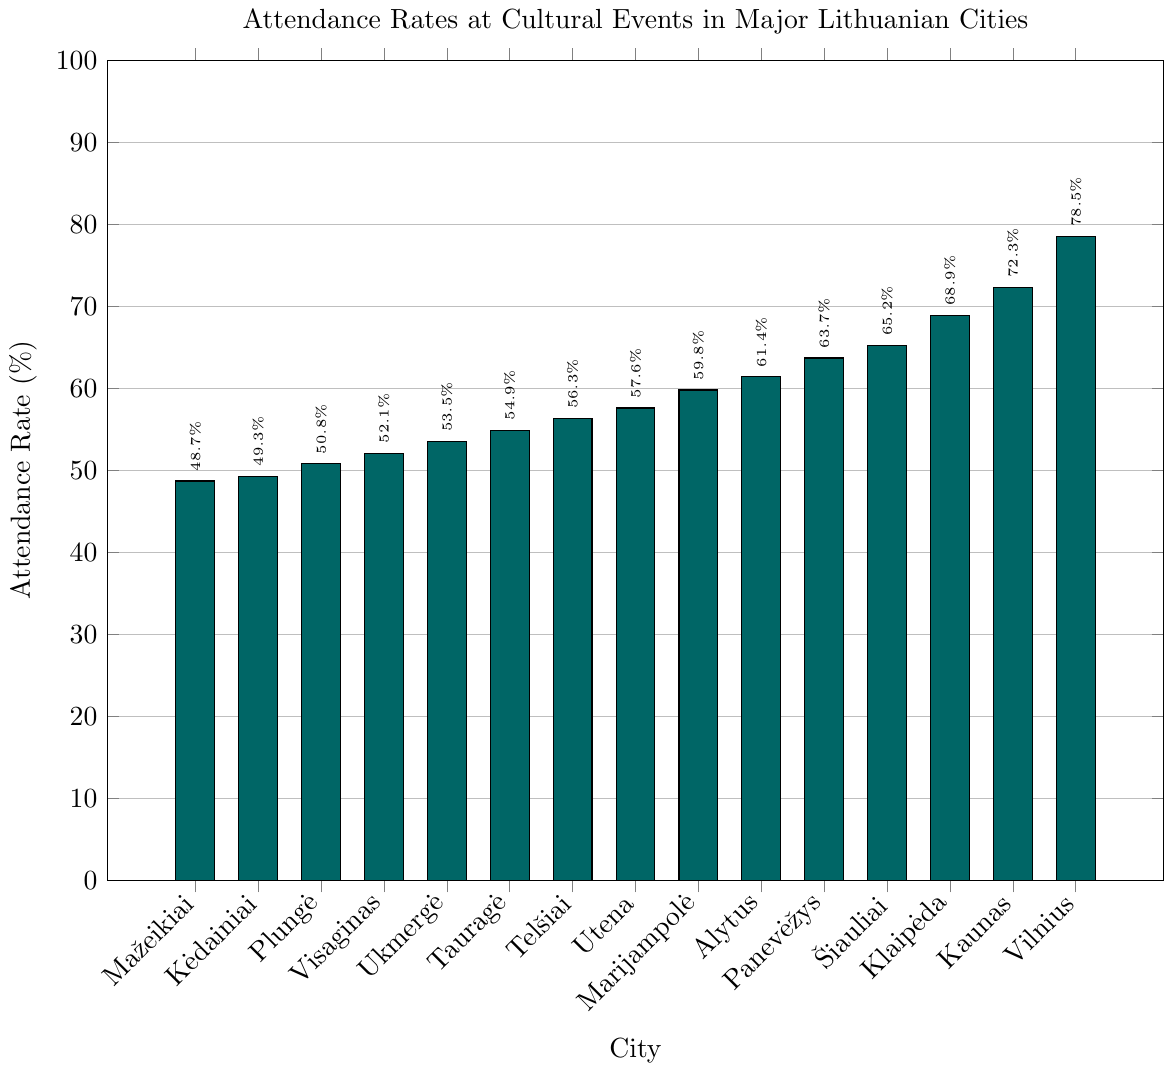Which city has the highest attendance rate at cultural events? The bar chart shows that Vilnius has the highest attendance rate, marked by the tallest bar.
Answer: Vilnius What is the attendance rate difference between Vilnius and Kaunas? The attendance rate for Vilnius is 78.5%, and for Kaunas, it is 72.3%. Subtracting these values gives 78.5 - 72.3 = 6.2%.
Answer: 6.2% Arrange the cities in order of descending attendance rates. From tallest to shortest bars, the cities are Vilnius, Kaunas, Klaipėda, Šiauliai, Panevėžys, Alytus, Marijampolė, Utena, Telšiai, Tauragė, Ukmergė, Visaginas, Plungė, Kėdainiai, Mažeikiai.
Answer: Vilnius, Kaunas, Klaipėda, Šiauliai, Panevėžys, Alytus, Marijampolė, Utena, Telšiai, Tauragė, Ukmergė, Visaginas, Plungė, Kėdainiai, Mažeikiai Which cities have an attendance rate above 60%? Cities with attendance rates above 60% according to the bar chart (bars higher than 60% mark): Vilnius, Kaunas, Klaipėda, Šiauliai, Panevėžys, Alytus, Marijampolė, Utena.
Answer: Vilnius, Kaunas, Klaipėda, Šiauliai, Panevėžys, Alytus, Marijampolė, Utena What is the average attendance rate of the five cities with the lowest rates? The five cities with the lowest rates are Mažeikiai (48.7%), Kėdainiai (49.3%), Plungė (50.8%), Visaginas (52.1%), Ukmergė (53.5%). The average is calculated as (48.7 + 49.3 + 50.8 + 52.1 + 53.5) / 5 = 50.88%.
Answer: 50.88% Which city is ranked fourth in attendance rate? The fourth highest bar in the chart corresponds to Šiauliai.
Answer: Šiauliai How much higher is the attendance rate in Vilnius compared to the average attendance rate of all cities? First, calculate the average attendance rate: Sum of all rates is 866.2. The number of cities is 15. Average = 866.2 / 15 = 57.75%. Difference = 78.5% - 57.75% = 20.75%.
Answer: 20.75% Identify which color represents the city with the sixth highest attendance rate. The sixth highest attendance rate corresponds to Alytus (61.4%). From observing the bar chart colors (left-to-right, where Alytus is sixth from right), identify the respective bar color, teal.
Answer: teal Compare the attendance rate of Šiauliai to the combined rate of Telšiai and Tauragė. Which is greater? Šiauliai has an attendance rate of 65.2%. The combined rate of Telšiai (56.3%) and Tauragė (54.9%) is 111.2%. Šiauliai (65.2%) < 111.2%.
Answer: Telšiai and Tauragė What is the median attendance rate? Order the attendance rates: 48.7, 49.3, 50.8, 52.1, 53.5, 54.9, 56.3, 57.6, 59.8, 61.4, 63.7, 65.2, 68.9, 72.3, 78.5. The median is the middle value, the 8th in a list of 15.
Answer: 57.6% 